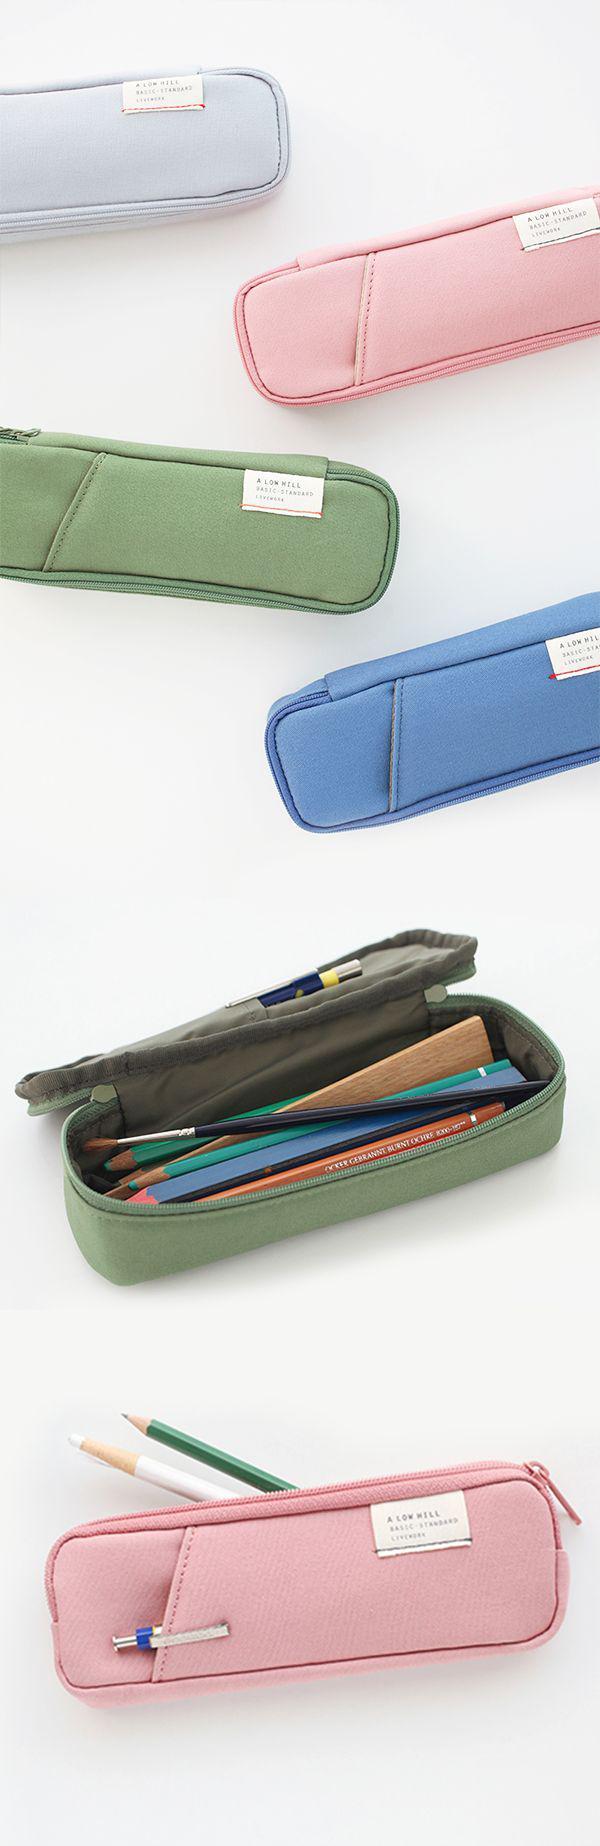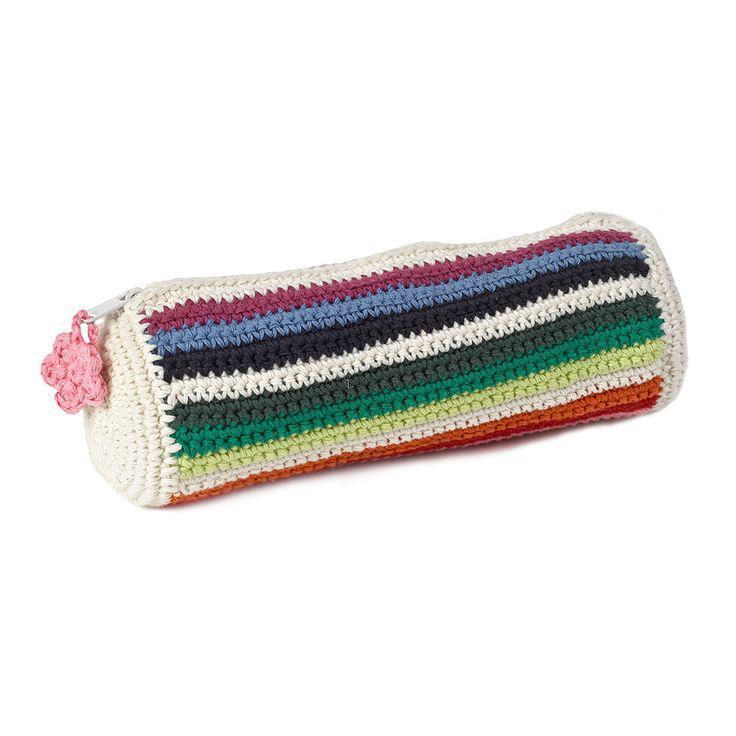The first image is the image on the left, the second image is the image on the right. Evaluate the accuracy of this statement regarding the images: "There is 1 pencil case that is fully open displaying pencils and pens.". Is it true? Answer yes or no. Yes. The first image is the image on the left, the second image is the image on the right. For the images displayed, is the sentence "The image to the left features exactly one case, and it is open." factually correct? Answer yes or no. No. 